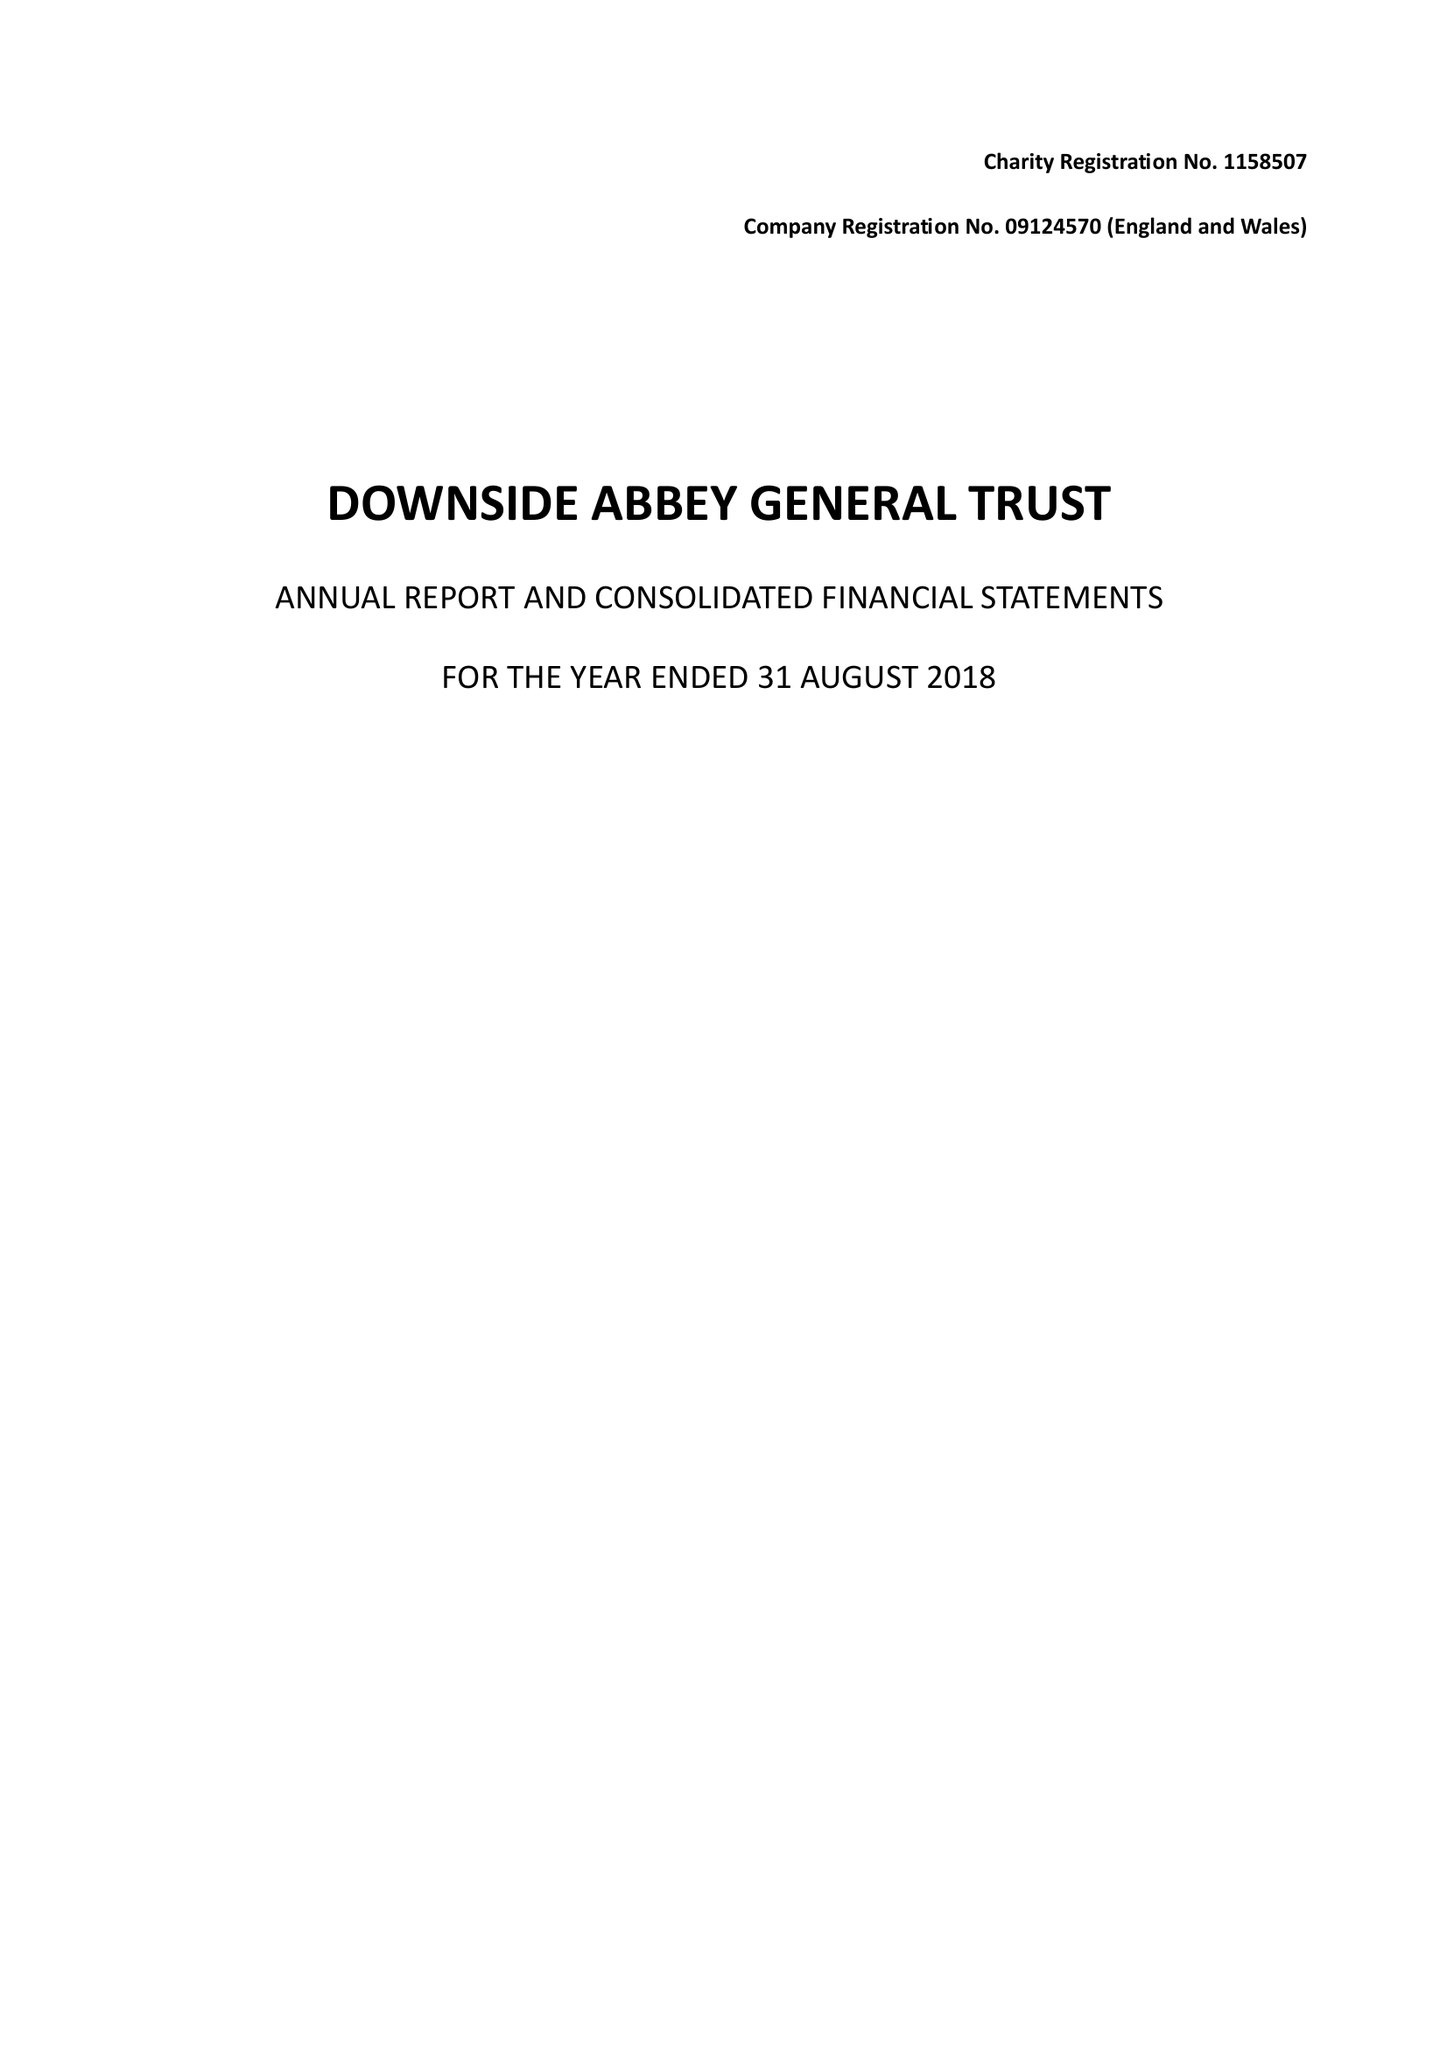What is the value for the report_date?
Answer the question using a single word or phrase. 2018-08-31 